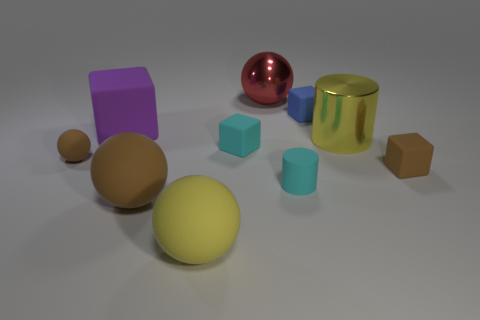Are there any patterns or themes that you observe in this arrangement? The arrangement showcases a variety of geometric shapes and colors, with a clear emphasis on simplicity and diversity. Each object carries unique properties - such as color, texture, and material - yet together they form a cohesive collection that might suggest themes of diversity within unity or the comparison between natural and man-made aesthetics. 